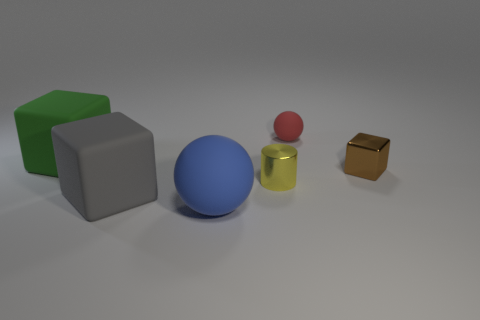Add 3 big green matte objects. How many objects exist? 9 Subtract all cylinders. How many objects are left? 5 Add 1 green blocks. How many green blocks exist? 2 Subtract 0 green spheres. How many objects are left? 6 Subtract all large yellow objects. Subtract all tiny cubes. How many objects are left? 5 Add 3 yellow things. How many yellow things are left? 4 